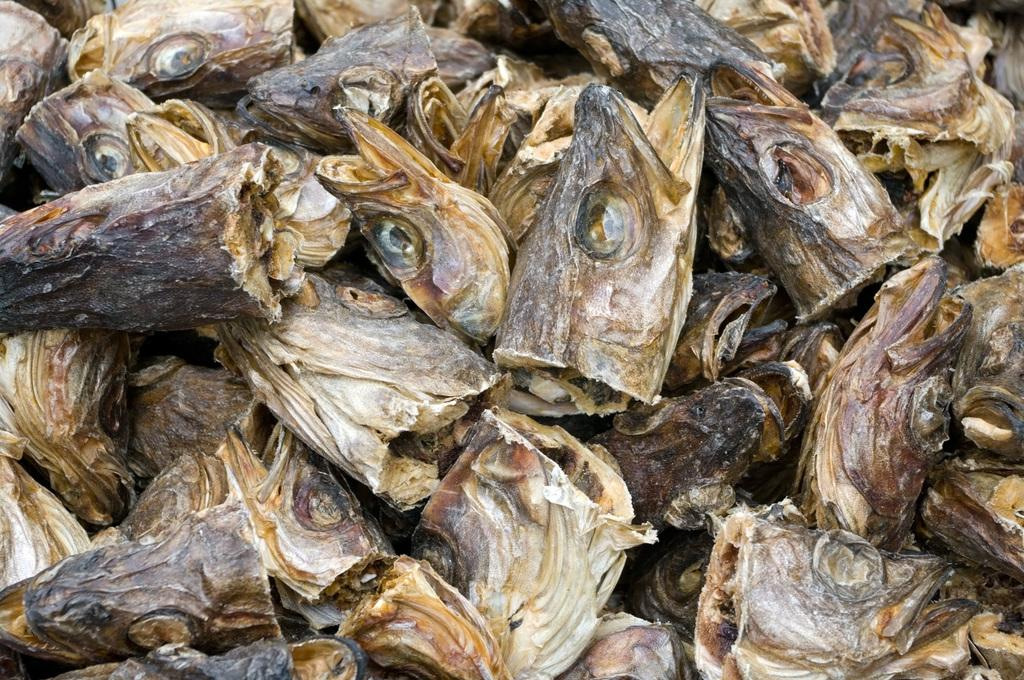What type of animal parts are present in the image? There are fish heads in the image. What type of industry is depicted in the image? There is no industry depicted in the image; it only features fish heads. What color is the coat worn by the person in the image? There is no person or coat present in the image; it only features fish heads. 